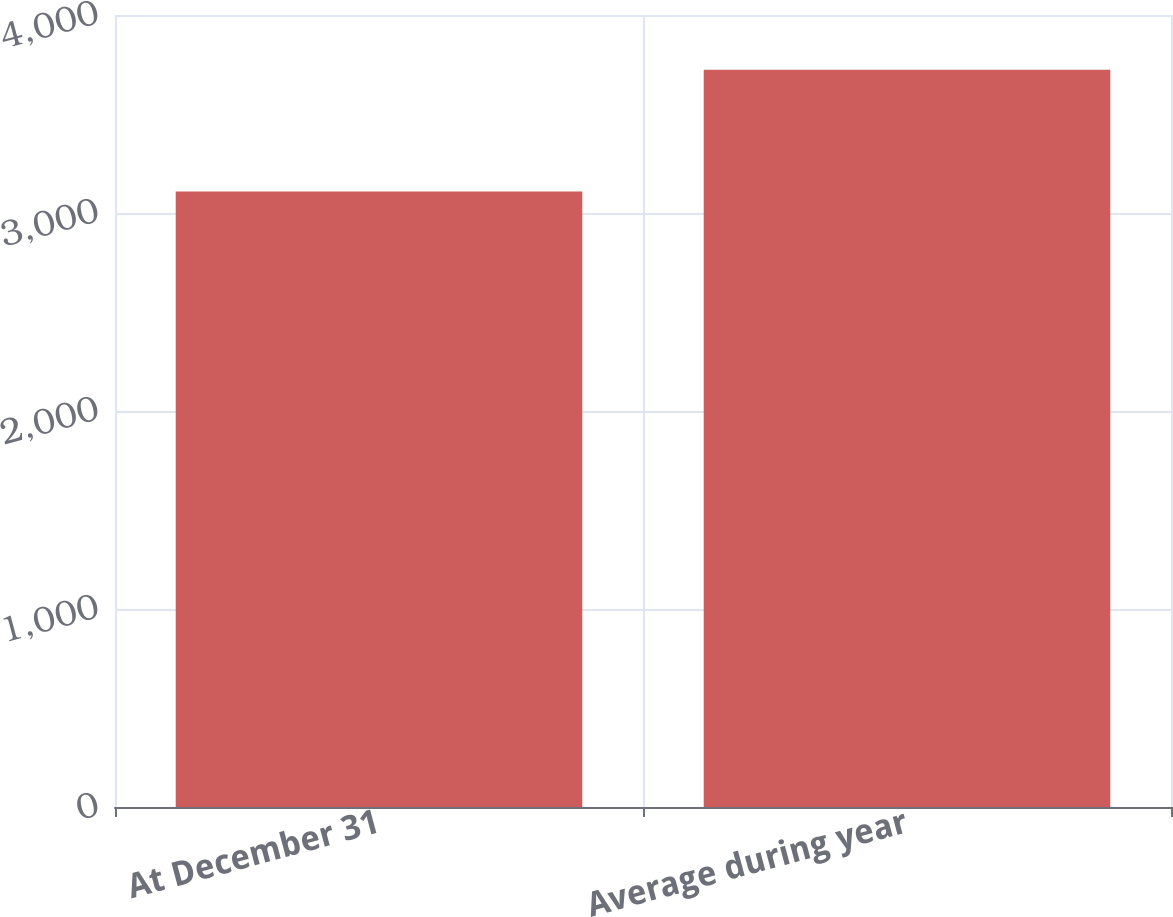Convert chart. <chart><loc_0><loc_0><loc_500><loc_500><bar_chart><fcel>At December 31<fcel>Average during year<nl><fcel>3108<fcel>3724<nl></chart> 